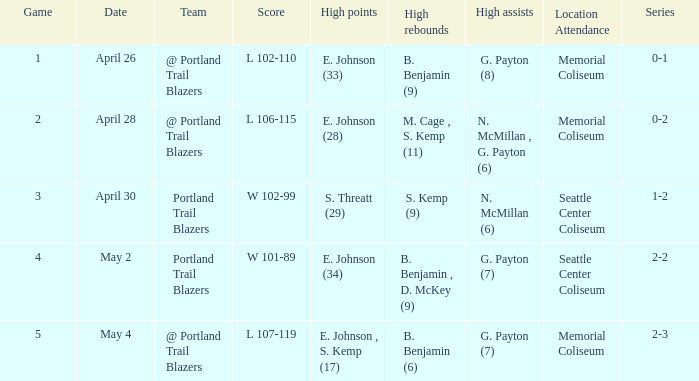With a 0-2 series, what is the high points? E. Johnson (28). 